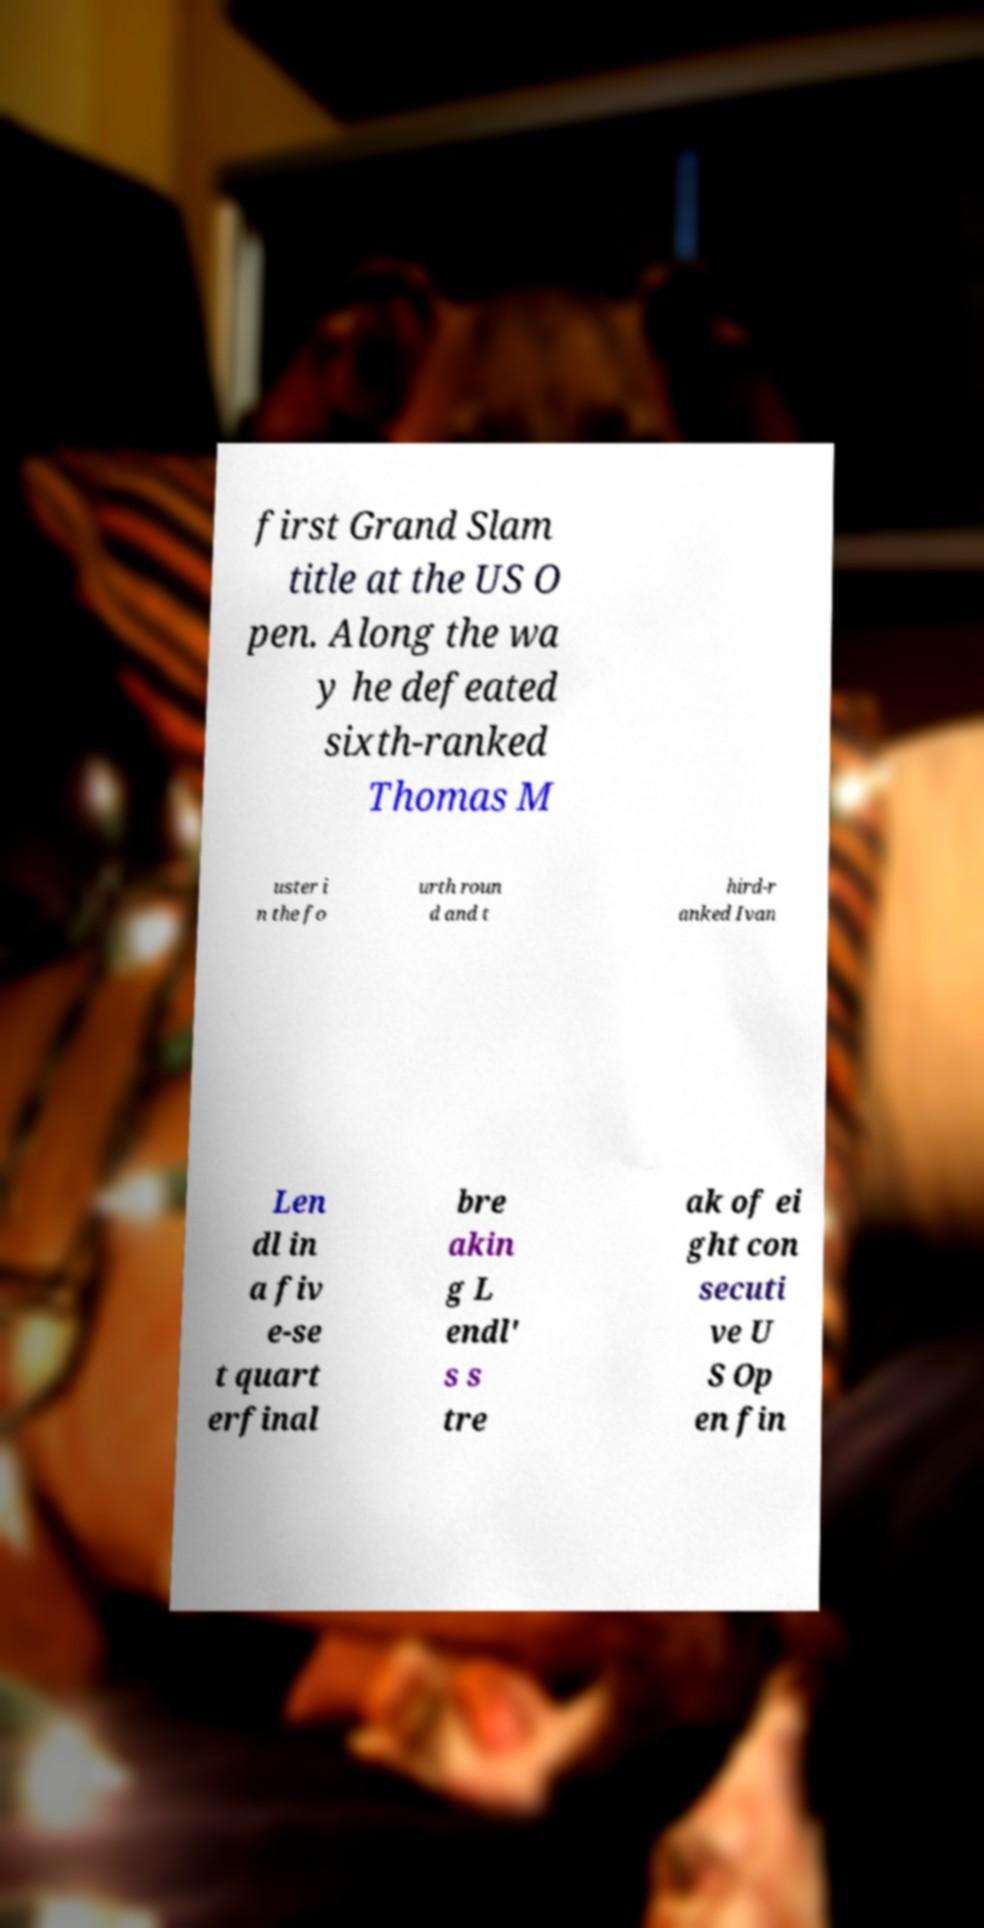Could you extract and type out the text from this image? first Grand Slam title at the US O pen. Along the wa y he defeated sixth-ranked Thomas M uster i n the fo urth roun d and t hird-r anked Ivan Len dl in a fiv e-se t quart erfinal bre akin g L endl' s s tre ak of ei ght con secuti ve U S Op en fin 